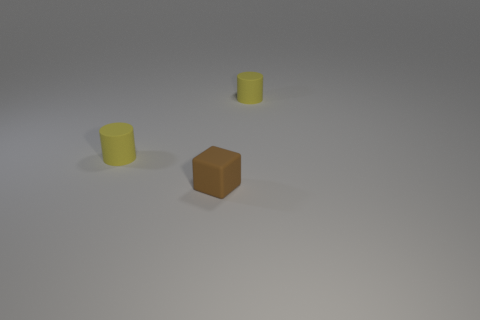There is a cylinder left of the thing right of the small brown block; how big is it?
Ensure brevity in your answer.  Small. Is there anything else of the same color as the small block?
Your response must be concise. No. Are the yellow thing left of the tiny brown rubber thing and the yellow cylinder on the right side of the brown thing made of the same material?
Your response must be concise. Yes. There is a brown matte thing; does it have the same shape as the tiny yellow rubber object right of the tiny cube?
Your answer should be compact. No. What is the material of the object behind the tiny yellow thing that is in front of the rubber object right of the brown matte block?
Offer a very short reply. Rubber. How many other things are there of the same size as the brown matte block?
Give a very brief answer. 2. There is a yellow matte cylinder in front of the small cylinder that is on the right side of the tiny rubber block; how many cylinders are behind it?
Your answer should be compact. 1. There is a yellow cylinder that is behind the object left of the small brown rubber cube; what is its material?
Keep it short and to the point. Rubber. Are there any large gray objects of the same shape as the small brown matte object?
Your answer should be very brief. No. How many things are either small objects right of the brown matte object or things that are behind the tiny brown cube?
Make the answer very short. 2. 